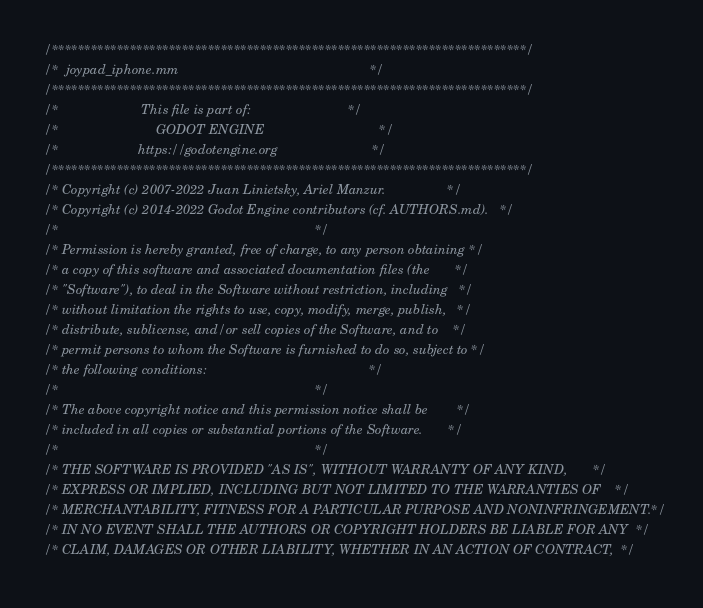<code> <loc_0><loc_0><loc_500><loc_500><_ObjectiveC_>/*************************************************************************/
/*  joypad_iphone.mm                                                     */
/*************************************************************************/
/*                       This file is part of:                           */
/*                           GODOT ENGINE                                */
/*                      https://godotengine.org                          */
/*************************************************************************/
/* Copyright (c) 2007-2022 Juan Linietsky, Ariel Manzur.                 */
/* Copyright (c) 2014-2022 Godot Engine contributors (cf. AUTHORS.md).   */
/*                                                                       */
/* Permission is hereby granted, free of charge, to any person obtaining */
/* a copy of this software and associated documentation files (the       */
/* "Software"), to deal in the Software without restriction, including   */
/* without limitation the rights to use, copy, modify, merge, publish,   */
/* distribute, sublicense, and/or sell copies of the Software, and to    */
/* permit persons to whom the Software is furnished to do so, subject to */
/* the following conditions:                                             */
/*                                                                       */
/* The above copyright notice and this permission notice shall be        */
/* included in all copies or substantial portions of the Software.       */
/*                                                                       */
/* THE SOFTWARE IS PROVIDED "AS IS", WITHOUT WARRANTY OF ANY KIND,       */
/* EXPRESS OR IMPLIED, INCLUDING BUT NOT LIMITED TO THE WARRANTIES OF    */
/* MERCHANTABILITY, FITNESS FOR A PARTICULAR PURPOSE AND NONINFRINGEMENT.*/
/* IN NO EVENT SHALL THE AUTHORS OR COPYRIGHT HOLDERS BE LIABLE FOR ANY  */
/* CLAIM, DAMAGES OR OTHER LIABILITY, WHETHER IN AN ACTION OF CONTRACT,  */</code> 